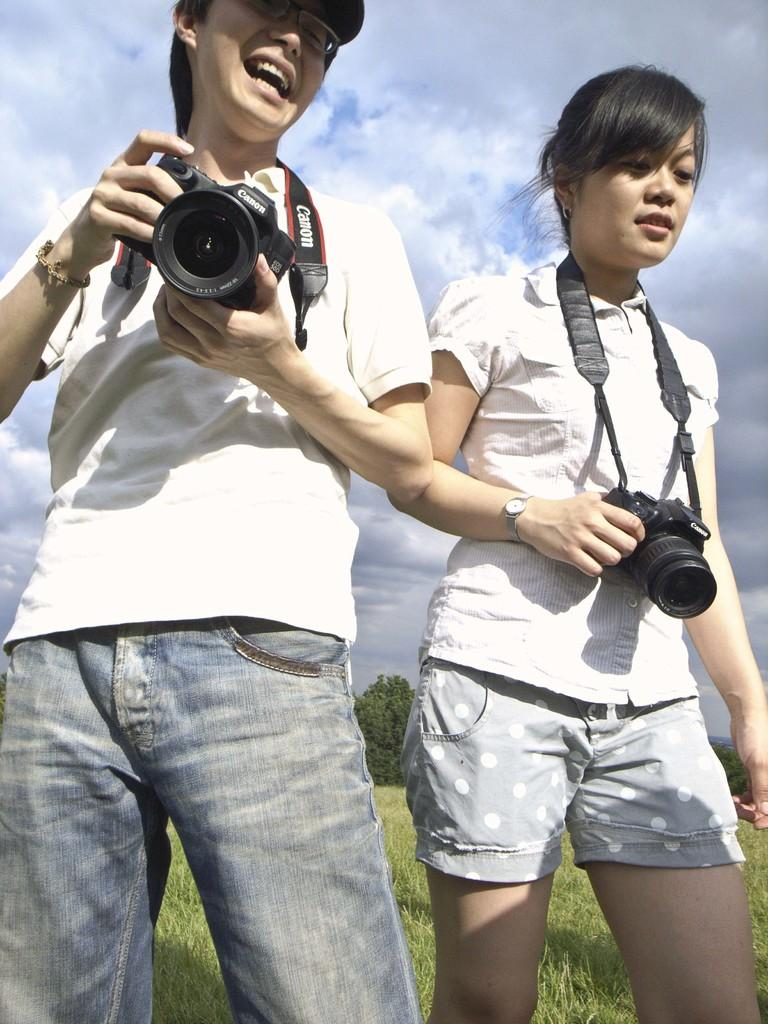Who are the people in the image? There is a man and a woman in the image. What are the man and woman holding in their hands? The man and woman are holding a camera in their hands. What type of pen is the father using to write in the image? There is no pen or father present in the image; it features a man and a woman holding a camera. 